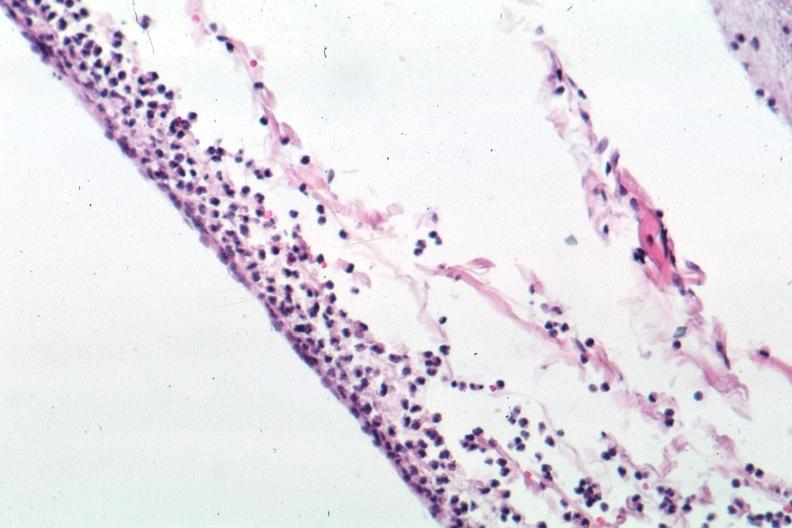s brain present?
Answer the question using a single word or phrase. Yes 